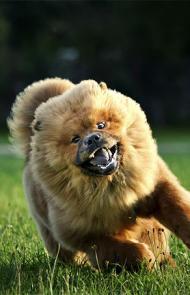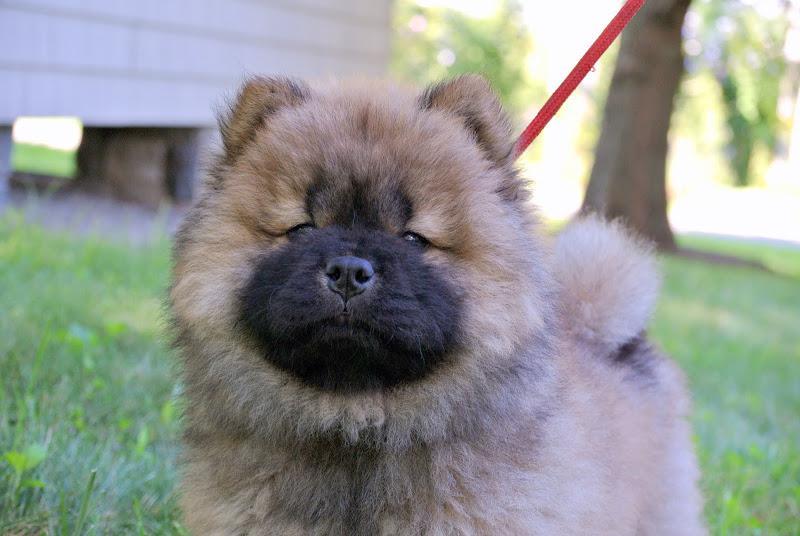The first image is the image on the left, the second image is the image on the right. Given the left and right images, does the statement "There are two dogs" hold true? Answer yes or no. Yes. The first image is the image on the left, the second image is the image on the right. Examine the images to the left and right. Is the description "Two young chows are side-by-side in one of the images." accurate? Answer yes or no. No. 